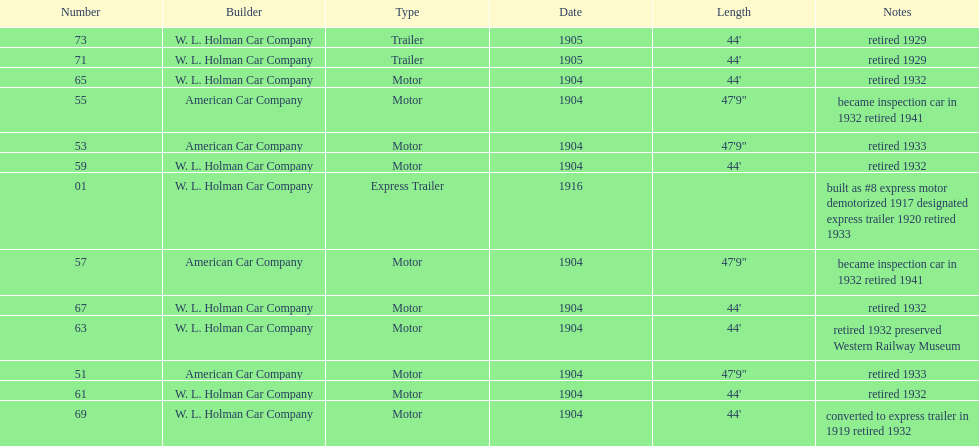Did american car company or w.l. holman car company build cars that were 44' in length? W. L. Holman Car Company. 